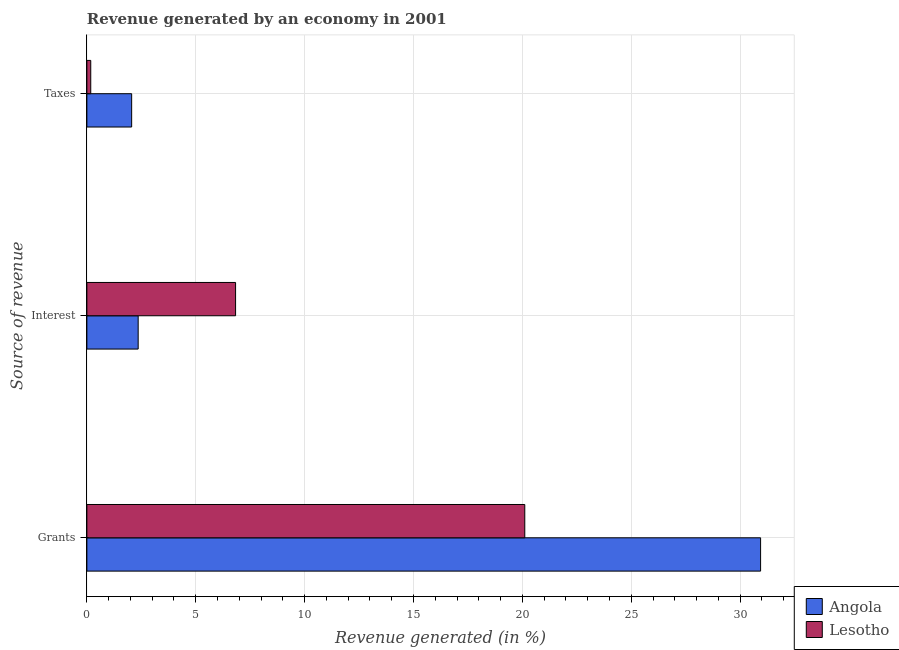How many different coloured bars are there?
Provide a succinct answer. 2. Are the number of bars on each tick of the Y-axis equal?
Keep it short and to the point. Yes. How many bars are there on the 2nd tick from the top?
Your response must be concise. 2. What is the label of the 2nd group of bars from the top?
Offer a very short reply. Interest. What is the percentage of revenue generated by taxes in Angola?
Give a very brief answer. 2.06. Across all countries, what is the maximum percentage of revenue generated by interest?
Offer a terse response. 6.83. Across all countries, what is the minimum percentage of revenue generated by interest?
Your response must be concise. 2.36. In which country was the percentage of revenue generated by grants maximum?
Your answer should be compact. Angola. In which country was the percentage of revenue generated by grants minimum?
Provide a succinct answer. Lesotho. What is the total percentage of revenue generated by grants in the graph?
Keep it short and to the point. 51.05. What is the difference between the percentage of revenue generated by grants in Angola and that in Lesotho?
Offer a very short reply. 10.83. What is the difference between the percentage of revenue generated by interest in Lesotho and the percentage of revenue generated by taxes in Angola?
Offer a very short reply. 4.77. What is the average percentage of revenue generated by taxes per country?
Keep it short and to the point. 1.12. What is the difference between the percentage of revenue generated by interest and percentage of revenue generated by taxes in Angola?
Ensure brevity in your answer.  0.3. What is the ratio of the percentage of revenue generated by grants in Angola to that in Lesotho?
Your answer should be very brief. 1.54. Is the difference between the percentage of revenue generated by grants in Angola and Lesotho greater than the difference between the percentage of revenue generated by taxes in Angola and Lesotho?
Provide a short and direct response. Yes. What is the difference between the highest and the second highest percentage of revenue generated by interest?
Your response must be concise. 4.47. What is the difference between the highest and the lowest percentage of revenue generated by grants?
Your answer should be very brief. 10.83. In how many countries, is the percentage of revenue generated by taxes greater than the average percentage of revenue generated by taxes taken over all countries?
Keep it short and to the point. 1. Is the sum of the percentage of revenue generated by grants in Angola and Lesotho greater than the maximum percentage of revenue generated by taxes across all countries?
Your answer should be very brief. Yes. What does the 2nd bar from the top in Taxes represents?
Your response must be concise. Angola. What does the 2nd bar from the bottom in Grants represents?
Make the answer very short. Lesotho. Is it the case that in every country, the sum of the percentage of revenue generated by grants and percentage of revenue generated by interest is greater than the percentage of revenue generated by taxes?
Offer a very short reply. Yes. Are all the bars in the graph horizontal?
Give a very brief answer. Yes. How many countries are there in the graph?
Your response must be concise. 2. What is the difference between two consecutive major ticks on the X-axis?
Offer a terse response. 5. Where does the legend appear in the graph?
Make the answer very short. Bottom right. How many legend labels are there?
Provide a succinct answer. 2. How are the legend labels stacked?
Your answer should be very brief. Vertical. What is the title of the graph?
Your answer should be compact. Revenue generated by an economy in 2001. Does "European Union" appear as one of the legend labels in the graph?
Give a very brief answer. No. What is the label or title of the X-axis?
Provide a succinct answer. Revenue generated (in %). What is the label or title of the Y-axis?
Give a very brief answer. Source of revenue. What is the Revenue generated (in %) of Angola in Grants?
Ensure brevity in your answer.  30.94. What is the Revenue generated (in %) of Lesotho in Grants?
Your response must be concise. 20.11. What is the Revenue generated (in %) in Angola in Interest?
Your answer should be very brief. 2.36. What is the Revenue generated (in %) of Lesotho in Interest?
Ensure brevity in your answer.  6.83. What is the Revenue generated (in %) of Angola in Taxes?
Provide a succinct answer. 2.06. What is the Revenue generated (in %) of Lesotho in Taxes?
Your answer should be compact. 0.18. Across all Source of revenue, what is the maximum Revenue generated (in %) in Angola?
Your answer should be compact. 30.94. Across all Source of revenue, what is the maximum Revenue generated (in %) of Lesotho?
Keep it short and to the point. 20.11. Across all Source of revenue, what is the minimum Revenue generated (in %) of Angola?
Offer a terse response. 2.06. Across all Source of revenue, what is the minimum Revenue generated (in %) in Lesotho?
Make the answer very short. 0.18. What is the total Revenue generated (in %) of Angola in the graph?
Your response must be concise. 35.35. What is the total Revenue generated (in %) in Lesotho in the graph?
Your answer should be compact. 27.12. What is the difference between the Revenue generated (in %) in Angola in Grants and that in Interest?
Give a very brief answer. 28.58. What is the difference between the Revenue generated (in %) of Lesotho in Grants and that in Interest?
Keep it short and to the point. 13.28. What is the difference between the Revenue generated (in %) in Angola in Grants and that in Taxes?
Offer a very short reply. 28.88. What is the difference between the Revenue generated (in %) of Lesotho in Grants and that in Taxes?
Your response must be concise. 19.93. What is the difference between the Revenue generated (in %) of Angola in Interest and that in Taxes?
Offer a terse response. 0.3. What is the difference between the Revenue generated (in %) in Lesotho in Interest and that in Taxes?
Make the answer very short. 6.65. What is the difference between the Revenue generated (in %) in Angola in Grants and the Revenue generated (in %) in Lesotho in Interest?
Ensure brevity in your answer.  24.11. What is the difference between the Revenue generated (in %) of Angola in Grants and the Revenue generated (in %) of Lesotho in Taxes?
Offer a very short reply. 30.76. What is the difference between the Revenue generated (in %) in Angola in Interest and the Revenue generated (in %) in Lesotho in Taxes?
Provide a short and direct response. 2.18. What is the average Revenue generated (in %) in Angola per Source of revenue?
Ensure brevity in your answer.  11.78. What is the average Revenue generated (in %) in Lesotho per Source of revenue?
Keep it short and to the point. 9.04. What is the difference between the Revenue generated (in %) in Angola and Revenue generated (in %) in Lesotho in Grants?
Give a very brief answer. 10.83. What is the difference between the Revenue generated (in %) in Angola and Revenue generated (in %) in Lesotho in Interest?
Offer a very short reply. -4.47. What is the difference between the Revenue generated (in %) of Angola and Revenue generated (in %) of Lesotho in Taxes?
Provide a short and direct response. 1.88. What is the ratio of the Revenue generated (in %) in Angola in Grants to that in Interest?
Provide a short and direct response. 13.14. What is the ratio of the Revenue generated (in %) in Lesotho in Grants to that in Interest?
Your answer should be compact. 2.94. What is the ratio of the Revenue generated (in %) of Angola in Grants to that in Taxes?
Make the answer very short. 15.05. What is the ratio of the Revenue generated (in %) in Lesotho in Grants to that in Taxes?
Your answer should be very brief. 112.96. What is the ratio of the Revenue generated (in %) in Angola in Interest to that in Taxes?
Your answer should be compact. 1.15. What is the ratio of the Revenue generated (in %) of Lesotho in Interest to that in Taxes?
Your answer should be compact. 38.36. What is the difference between the highest and the second highest Revenue generated (in %) in Angola?
Provide a short and direct response. 28.58. What is the difference between the highest and the second highest Revenue generated (in %) of Lesotho?
Give a very brief answer. 13.28. What is the difference between the highest and the lowest Revenue generated (in %) in Angola?
Your answer should be compact. 28.88. What is the difference between the highest and the lowest Revenue generated (in %) in Lesotho?
Keep it short and to the point. 19.93. 